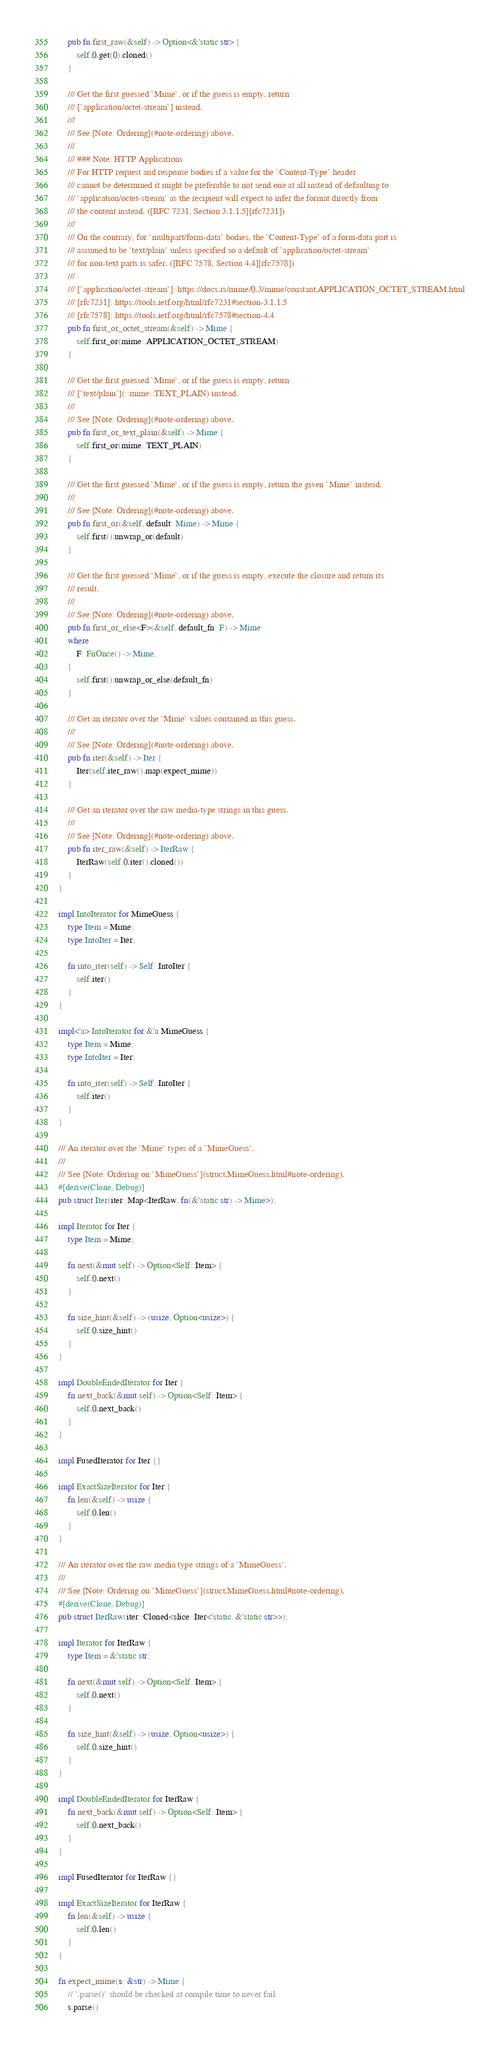<code> <loc_0><loc_0><loc_500><loc_500><_Rust_>    pub fn first_raw(&self) -> Option<&'static str> {
        self.0.get(0).cloned()
    }

    /// Get the first guessed `Mime`, or if the guess is empty, return
    /// [`application/octet-stream`] instead.
    ///
    /// See [Note: Ordering](#note-ordering) above.
    ///
    /// ### Note: HTTP Applications
    /// For HTTP request and response bodies if a value for the `Content-Type` header
    /// cannot be determined it might be preferable to not send one at all instead of defaulting to
    /// `application/octet-stream` as the recipient will expect to infer the format directly from
    /// the content instead. ([RFC 7231, Section 3.1.1.5][rfc7231])
    ///
    /// On the contrary, for `multipart/form-data` bodies, the `Content-Type` of a form-data part is
    /// assumed to be `text/plain` unless specified so a default of `application/octet-stream`
    /// for non-text parts is safer. ([RFC 7578, Section 4.4][rfc7578])
    ///
    /// [`application/octet-stream`]: https://docs.rs/mime/0.3/mime/constant.APPLICATION_OCTET_STREAM.html
    /// [rfc7231]: https://tools.ietf.org/html/rfc7231#section-3.1.1.5
    /// [rfc7578]: https://tools.ietf.org/html/rfc7578#section-4.4
    pub fn first_or_octet_stream(&self) -> Mime {
        self.first_or(mime::APPLICATION_OCTET_STREAM)
    }

    /// Get the first guessed `Mime`, or if the guess is empty, return
    /// [`text/plain`](::mime::TEXT_PLAIN) instead.
    ///
    /// See [Note: Ordering](#note-ordering) above.
    pub fn first_or_text_plain(&self) -> Mime {
        self.first_or(mime::TEXT_PLAIN)
    }

    /// Get the first guessed `Mime`, or if the guess is empty, return the given `Mime` instead.
    ///
    /// See [Note: Ordering](#note-ordering) above.
    pub fn first_or(&self, default: Mime) -> Mime {
        self.first().unwrap_or(default)
    }

    /// Get the first guessed `Mime`, or if the guess is empty, execute the closure and return its
    /// result.
    ///
    /// See [Note: Ordering](#note-ordering) above.
    pub fn first_or_else<F>(&self, default_fn: F) -> Mime
    where
        F: FnOnce() -> Mime,
    {
        self.first().unwrap_or_else(default_fn)
    }

    /// Get an iterator over the `Mime` values contained in this guess.
    ///
    /// See [Note: Ordering](#note-ordering) above.
    pub fn iter(&self) -> Iter {
        Iter(self.iter_raw().map(expect_mime))
    }

    /// Get an iterator over the raw media-type strings in this guess.
    ///
    /// See [Note: Ordering](#note-ordering) above.
    pub fn iter_raw(&self) -> IterRaw {
        IterRaw(self.0.iter().cloned())
    }
}

impl IntoIterator for MimeGuess {
    type Item = Mime;
    type IntoIter = Iter;

    fn into_iter(self) -> Self::IntoIter {
        self.iter()
    }
}

impl<'a> IntoIterator for &'a MimeGuess {
    type Item = Mime;
    type IntoIter = Iter;

    fn into_iter(self) -> Self::IntoIter {
        self.iter()
    }
}

/// An iterator over the `Mime` types of a `MimeGuess`.
///
/// See [Note: Ordering on `MimeGuess`](struct.MimeGuess.html#note-ordering).
#[derive(Clone, Debug)]
pub struct Iter(iter::Map<IterRaw, fn(&'static str) -> Mime>);

impl Iterator for Iter {
    type Item = Mime;

    fn next(&mut self) -> Option<Self::Item> {
        self.0.next()
    }

    fn size_hint(&self) -> (usize, Option<usize>) {
        self.0.size_hint()
    }
}

impl DoubleEndedIterator for Iter {
    fn next_back(&mut self) -> Option<Self::Item> {
        self.0.next_back()
    }
}

impl FusedIterator for Iter {}

impl ExactSizeIterator for Iter {
    fn len(&self) -> usize {
        self.0.len()
    }
}

/// An iterator over the raw media type strings of a `MimeGuess`.
///
/// See [Note: Ordering on `MimeGuess`](struct.MimeGuess.html#note-ordering).
#[derive(Clone, Debug)]
pub struct IterRaw(iter::Cloned<slice::Iter<'static, &'static str>>);

impl Iterator for IterRaw {
    type Item = &'static str;

    fn next(&mut self) -> Option<Self::Item> {
        self.0.next()
    }

    fn size_hint(&self) -> (usize, Option<usize>) {
        self.0.size_hint()
    }
}

impl DoubleEndedIterator for IterRaw {
    fn next_back(&mut self) -> Option<Self::Item> {
        self.0.next_back()
    }
}

impl FusedIterator for IterRaw {}

impl ExactSizeIterator for IterRaw {
    fn len(&self) -> usize {
        self.0.len()
    }
}

fn expect_mime(s: &str) -> Mime {
    // `.parse()` should be checked at compile time to never fail
    s.parse()</code> 